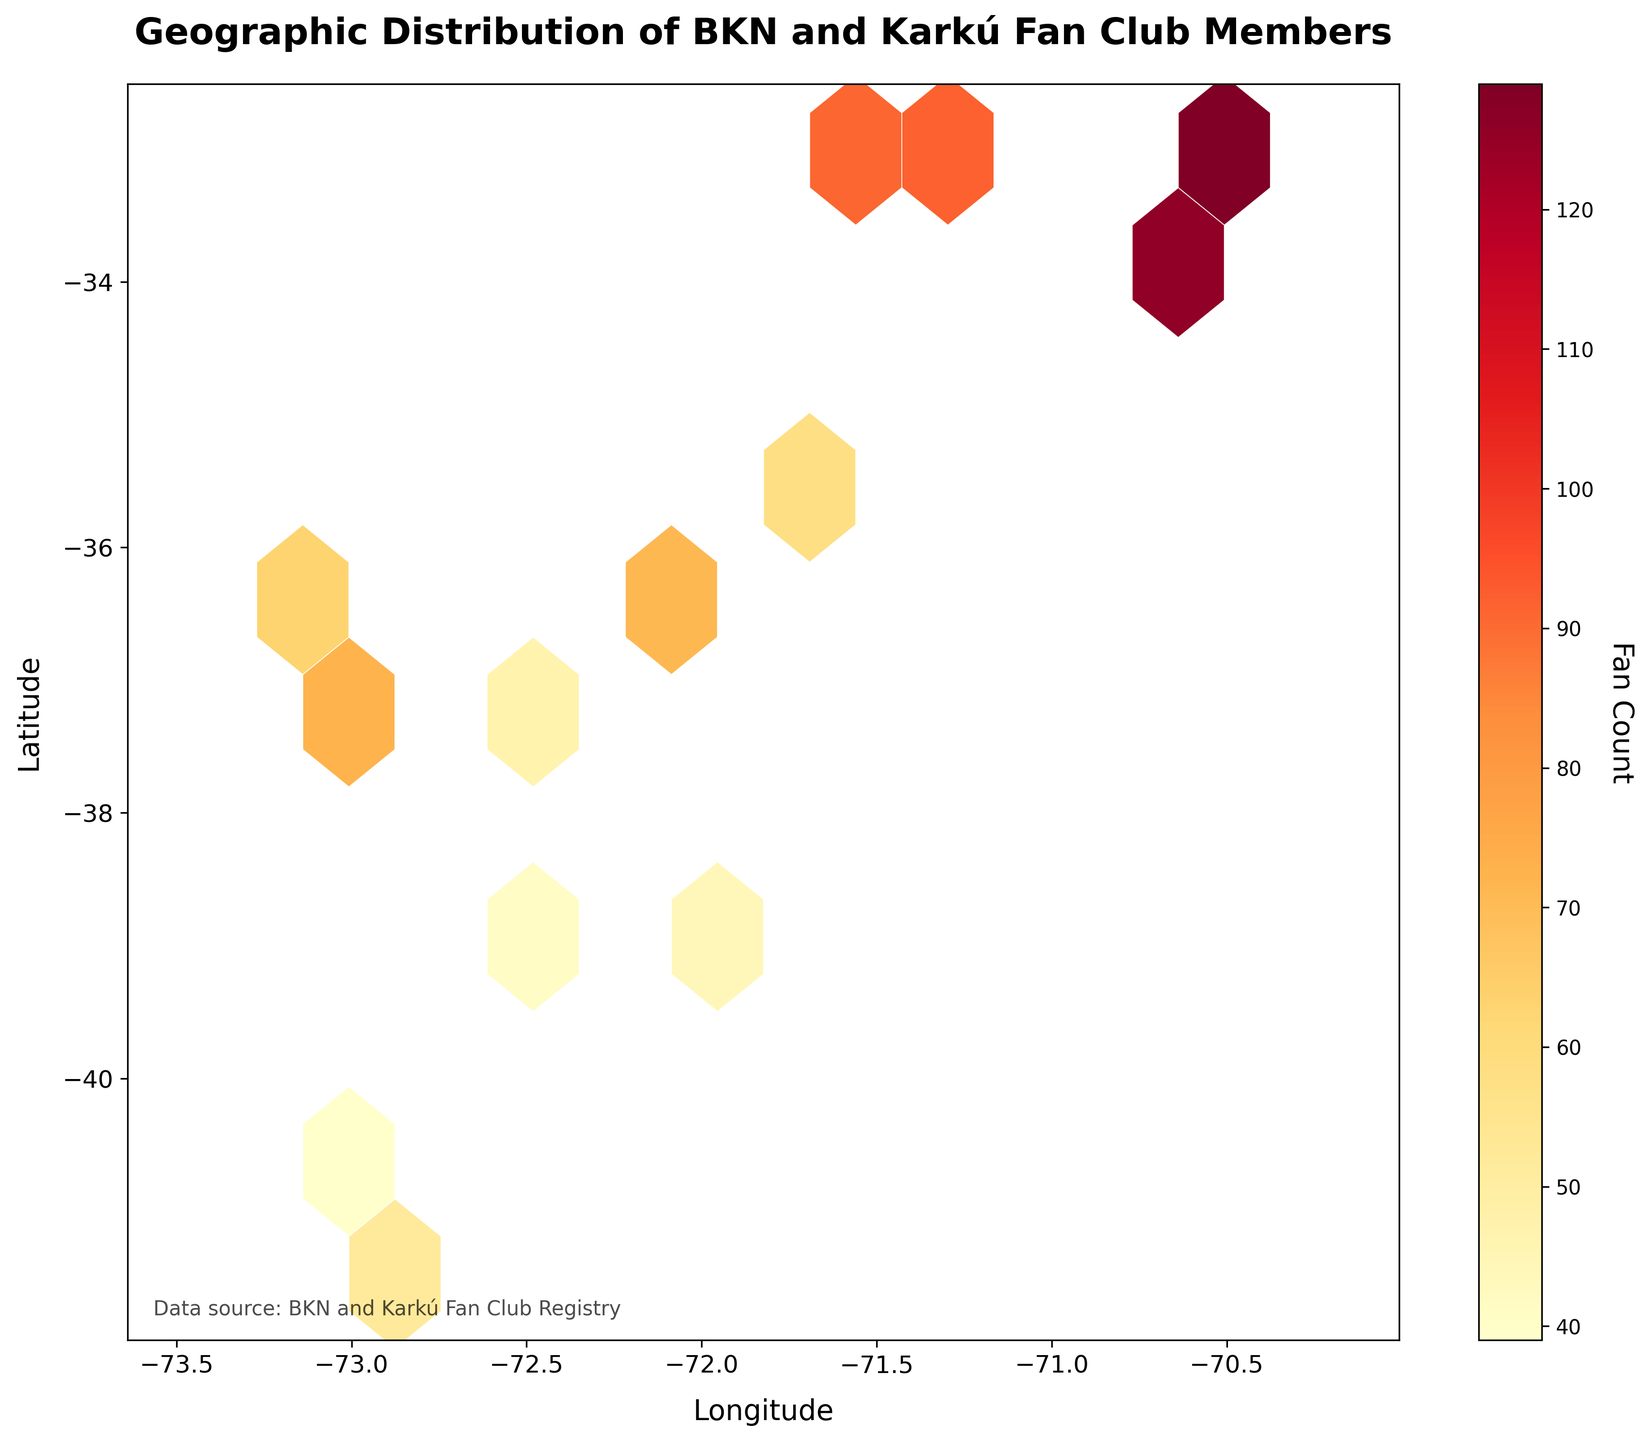What is the title of the plot? The title is found at the top of the plot in bold text, which is "Geographic Distribution of BKN and Karkú Fan Club Members".
Answer: Geographic Distribution of BKN and Karkú Fan Club Members What do the axes represent? The x-axis represents Longitude and the y-axis represents Latitude, as denoted by the labels on the respective axes.
Answer: Longitude (x-axis) and Latitude (y-axis) What color scale is used to represent fan count? The color scale ranging from light yellow to red is used to represent fan count, with lighter colors indicating lower counts and darker colors indicating higher counts.
Answer: Light yellow to red What is the range of longitudes in the plot? The x-axis ranges from just below -72 to just above -70. These values are visible by looking at the tick marks on the x-axis.
Answer: -72 to -70 Which geographical area shows the highest concentration of fan counts? The area around the coordinates (-33.4489, -70.6693) has the darkest hexagons, which indicates the highest concentration of fan counts.
Answer: Around (-33.4489, -70.6693) What is the maximum fan count observed in any hexagon? By observing the color bar, the darkest hexagon correlates to approximately 145 fans. This information is represented by the darkest color and its corresponding value on the color scale.
Answer: Approximately 145 fans How is fan distribution indicated in this figure? Fan distribution is visualized using a hexagonal binning plot, where each hexagon's color intensity represents the number of fans in that geographic area.
Answer: Hexagonal binning plot Are there more fans located to the north or south of latitude -35? By comparing the color intensity of hexagons above and below latitude -35, the regions north of -35 show more and darker hexagons, indicating a higher fan concentration.
Answer: North of -35 Which area has a lower fan concentration, around longitude -71.6 or -72.1? Observing the plot, the area around longitude -72.1 has hexagons with lighter colors compared to those around -71.6, indicating a lower fan concentration.
Answer: Around longitude -72.1 What is the trend of fan counts as you move from west to east? As you move from west (left side) to east (right side) on the plot, the fan counts tend to increase, shown by the hexagons becoming darker.
Answer: Fan counts increase from west to east 